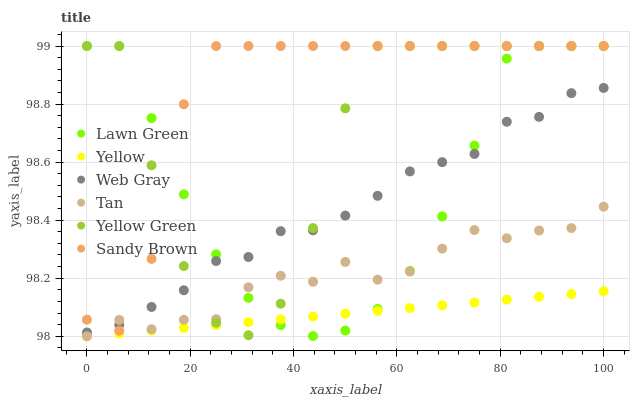Does Yellow have the minimum area under the curve?
Answer yes or no. Yes. Does Sandy Brown have the maximum area under the curve?
Answer yes or no. Yes. Does Web Gray have the minimum area under the curve?
Answer yes or no. No. Does Web Gray have the maximum area under the curve?
Answer yes or no. No. Is Yellow the smoothest?
Answer yes or no. Yes. Is Yellow Green the roughest?
Answer yes or no. Yes. Is Web Gray the smoothest?
Answer yes or no. No. Is Web Gray the roughest?
Answer yes or no. No. Does Yellow have the lowest value?
Answer yes or no. Yes. Does Web Gray have the lowest value?
Answer yes or no. No. Does Sandy Brown have the highest value?
Answer yes or no. Yes. Does Web Gray have the highest value?
Answer yes or no. No. Is Yellow less than Web Gray?
Answer yes or no. Yes. Is Web Gray greater than Yellow?
Answer yes or no. Yes. Does Web Gray intersect Tan?
Answer yes or no. Yes. Is Web Gray less than Tan?
Answer yes or no. No. Is Web Gray greater than Tan?
Answer yes or no. No. Does Yellow intersect Web Gray?
Answer yes or no. No. 